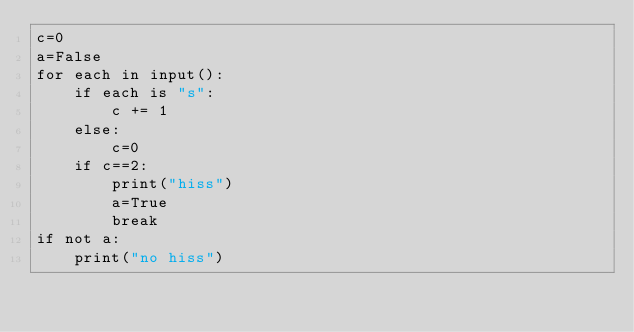Convert code to text. <code><loc_0><loc_0><loc_500><loc_500><_Python_>c=0
a=False
for each in input():
    if each is "s":
        c += 1
    else:
        c=0
    if c==2:
        print("hiss")
        a=True
        break
if not a:
    print("no hiss")
</code> 